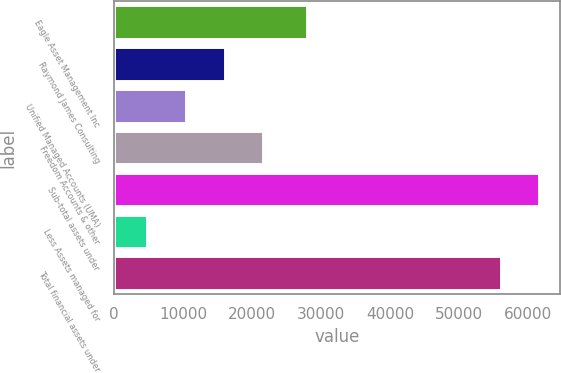Convert chart. <chart><loc_0><loc_0><loc_500><loc_500><bar_chart><fcel>Eagle Asset Management Inc<fcel>Raymond James Consulting<fcel>Unified Managed Accounts (UMA)<fcel>Freedom Accounts & other<fcel>Sub-total assets under<fcel>Less Assets managed for<fcel>Total financial assets under<nl><fcel>27886<fcel>15996.8<fcel>10397.9<fcel>21595.7<fcel>61587.9<fcel>4799<fcel>55989<nl></chart> 